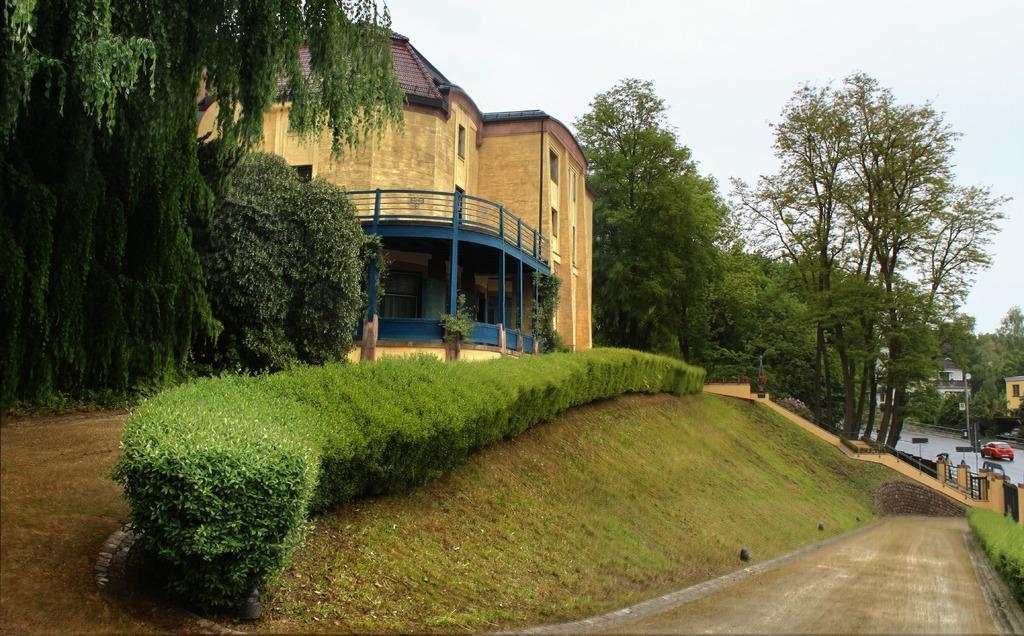Could you give a brief overview of what you see in this image? In this image there is the sky truncated towards the top of the image, there are buildings, there are buildings truncated towards the right of the image, there are trees, there are trees truncated towards the right of the image, there are trees truncated towards the left of the image, there are trees truncated towards the top of the image, there are plants, there is the road truncated towards the right of the image, there are vehicles on the road, there are plants truncated towards the right of the image, there is a gate, there is the ground truncated towards the bottom of the image. 